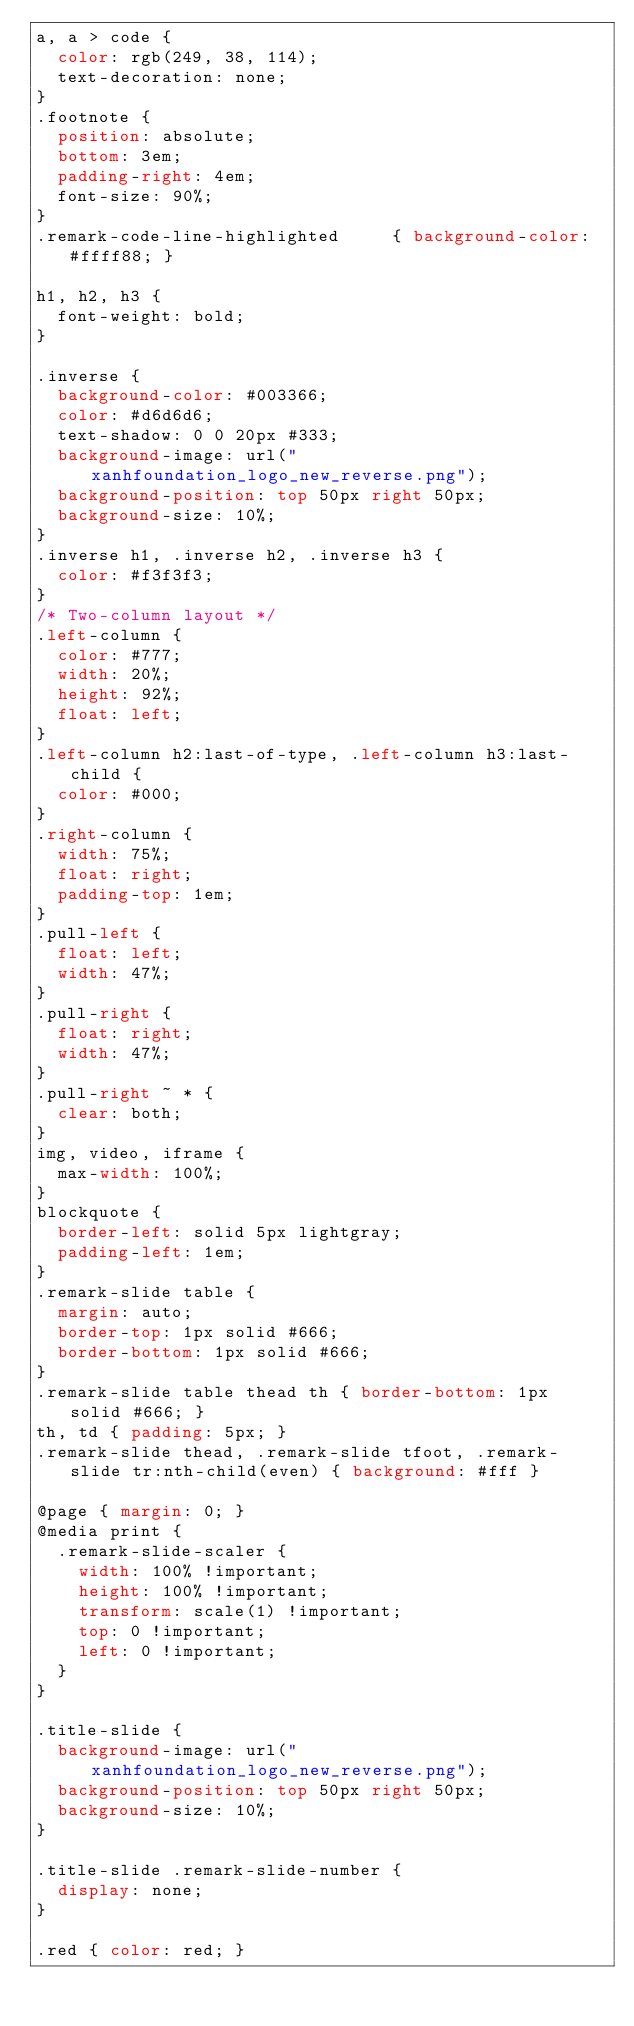Convert code to text. <code><loc_0><loc_0><loc_500><loc_500><_CSS_>a, a > code {
  color: rgb(249, 38, 114);
  text-decoration: none;
}
.footnote {
  position: absolute;
  bottom: 3em;
  padding-right: 4em;
  font-size: 90%;
}
.remark-code-line-highlighted     { background-color: #ffff88; }

h1, h2, h3 {
  font-weight: bold;
}

.inverse {
  background-color: #003366;
  color: #d6d6d6;
  text-shadow: 0 0 20px #333;
  background-image: url("xanhfoundation_logo_new_reverse.png");
  background-position: top 50px right 50px;
  background-size: 10%;
}
.inverse h1, .inverse h2, .inverse h3 {
  color: #f3f3f3;
}
/* Two-column layout */
.left-column {
  color: #777;
  width: 20%;
  height: 92%;
  float: left;
}
.left-column h2:last-of-type, .left-column h3:last-child {
  color: #000;
}
.right-column {
  width: 75%;
  float: right;
  padding-top: 1em;
}
.pull-left {
  float: left;
  width: 47%;
}
.pull-right {
  float: right;
  width: 47%;
}
.pull-right ~ * {
  clear: both;
}
img, video, iframe {
  max-width: 100%;
}
blockquote {
  border-left: solid 5px lightgray;
  padding-left: 1em;
}
.remark-slide table {
  margin: auto;
  border-top: 1px solid #666;
  border-bottom: 1px solid #666;
}
.remark-slide table thead th { border-bottom: 1px solid #666; }
th, td { padding: 5px; }
.remark-slide thead, .remark-slide tfoot, .remark-slide tr:nth-child(even) { background: #fff }

@page { margin: 0; }
@media print {
  .remark-slide-scaler {
    width: 100% !important;
    height: 100% !important;
    transform: scale(1) !important;
    top: 0 !important;
    left: 0 !important;
  }
}

.title-slide {
  background-image: url("xanhfoundation_logo_new_reverse.png");
  background-position: top 50px right 50px;
  background-size: 10%;
}

.title-slide .remark-slide-number {
  display: none;
}

.red { color: red; }</code> 